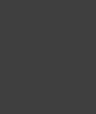<code> <loc_0><loc_0><loc_500><loc_500><_Java_>
</code> 